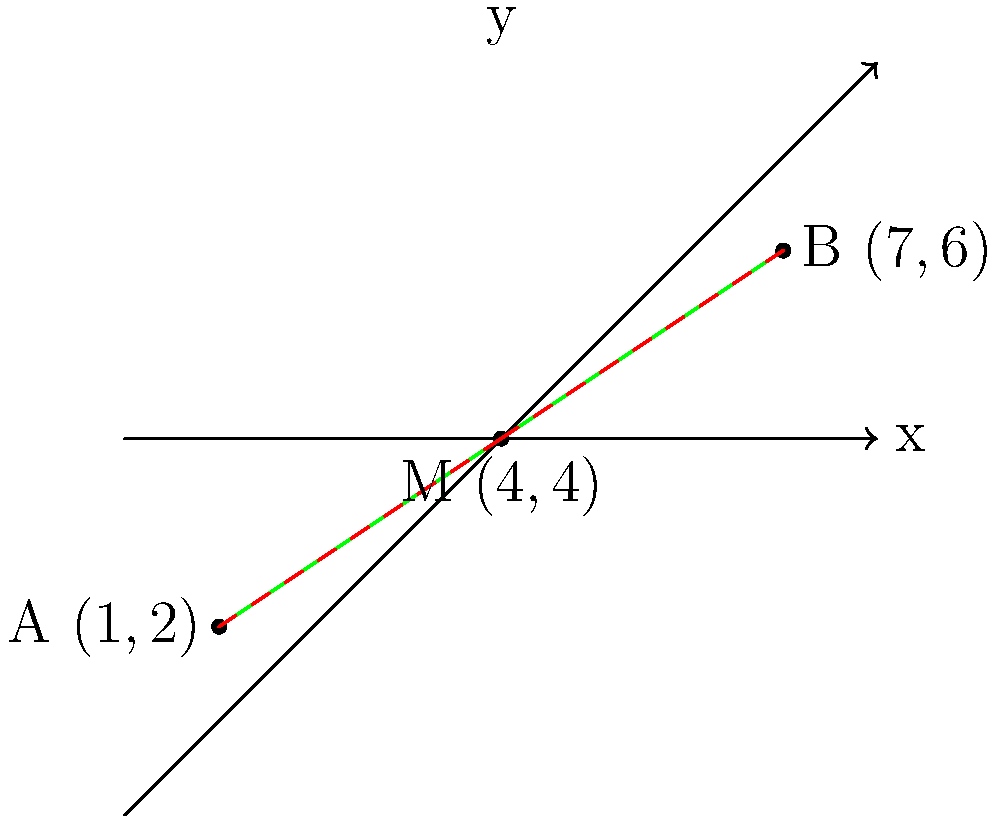Two eco-friendly fabric manufacturing facilities are located at coordinates A(1,2) and B(7,6) on a map. To optimize transportation and resource sharing, you need to establish a central distribution point at the midpoint between these two facilities. What are the coordinates of this midpoint? To find the midpoint M between two points A(x₁, y₁) and B(x₂, y₂), we use the midpoint formula:

$$ M_x = \frac{x_1 + x_2}{2}, \quad M_y = \frac{y_1 + y_2}{2} $$

Given:
A(1,2) and B(7,6)

Step 1: Calculate the x-coordinate of the midpoint:
$$ M_x = \frac{x_1 + x_2}{2} = \frac{1 + 7}{2} = \frac{8}{2} = 4 $$

Step 2: Calculate the y-coordinate of the midpoint:
$$ M_y = \frac{y_1 + y_2}{2} = \frac{2 + 6}{2} = \frac{8}{2} = 4 $$

Step 3: Combine the results to get the midpoint coordinates:
M(4,4)

Therefore, the central distribution point should be established at coordinates (4,4).
Answer: (4,4) 